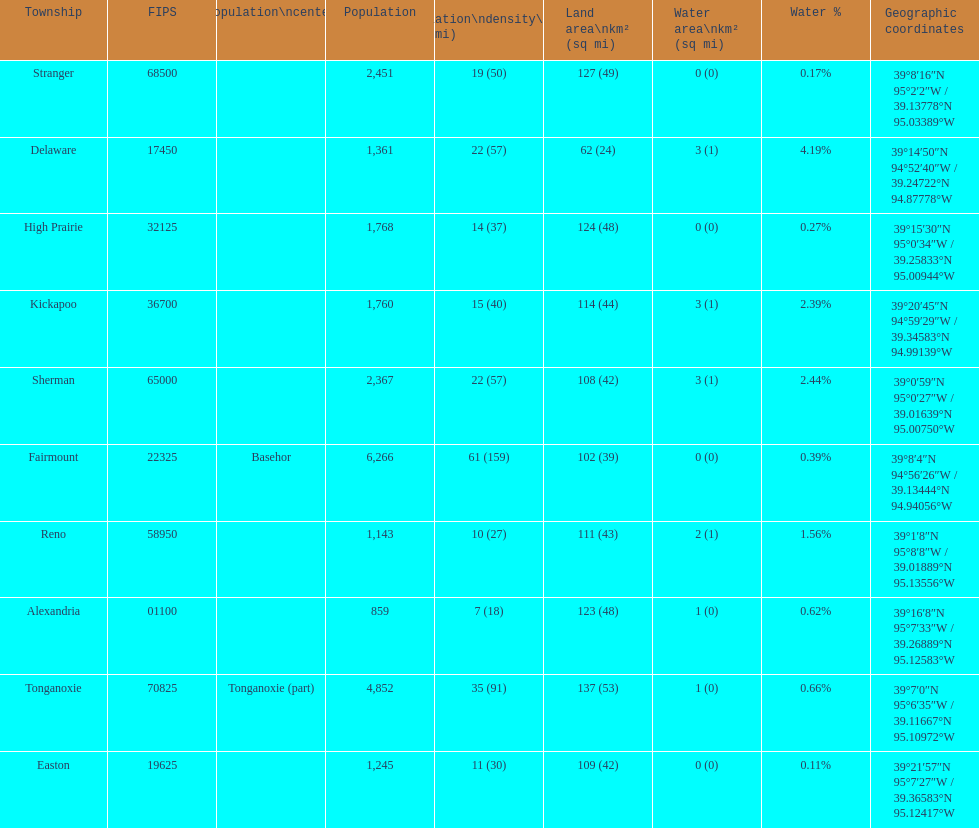What is the difference of population in easton and reno? 102. 